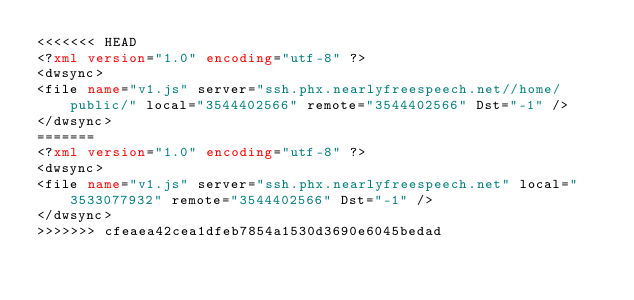Convert code to text. <code><loc_0><loc_0><loc_500><loc_500><_XML_><<<<<<< HEAD
<?xml version="1.0" encoding="utf-8" ?><dwsync><file name="v1.js" server="ssh.phx.nearlyfreespeech.net//home/public/" local="3544402566" remote="3544402566" Dst="-1" /></dwsync>
=======
<?xml version="1.0" encoding="utf-8" ?><dwsync><file name="v1.js" server="ssh.phx.nearlyfreespeech.net" local="3533077932" remote="3544402566" Dst="-1" /></dwsync>
>>>>>>> cfeaea42cea1dfeb7854a1530d3690e6045bedad
</code> 